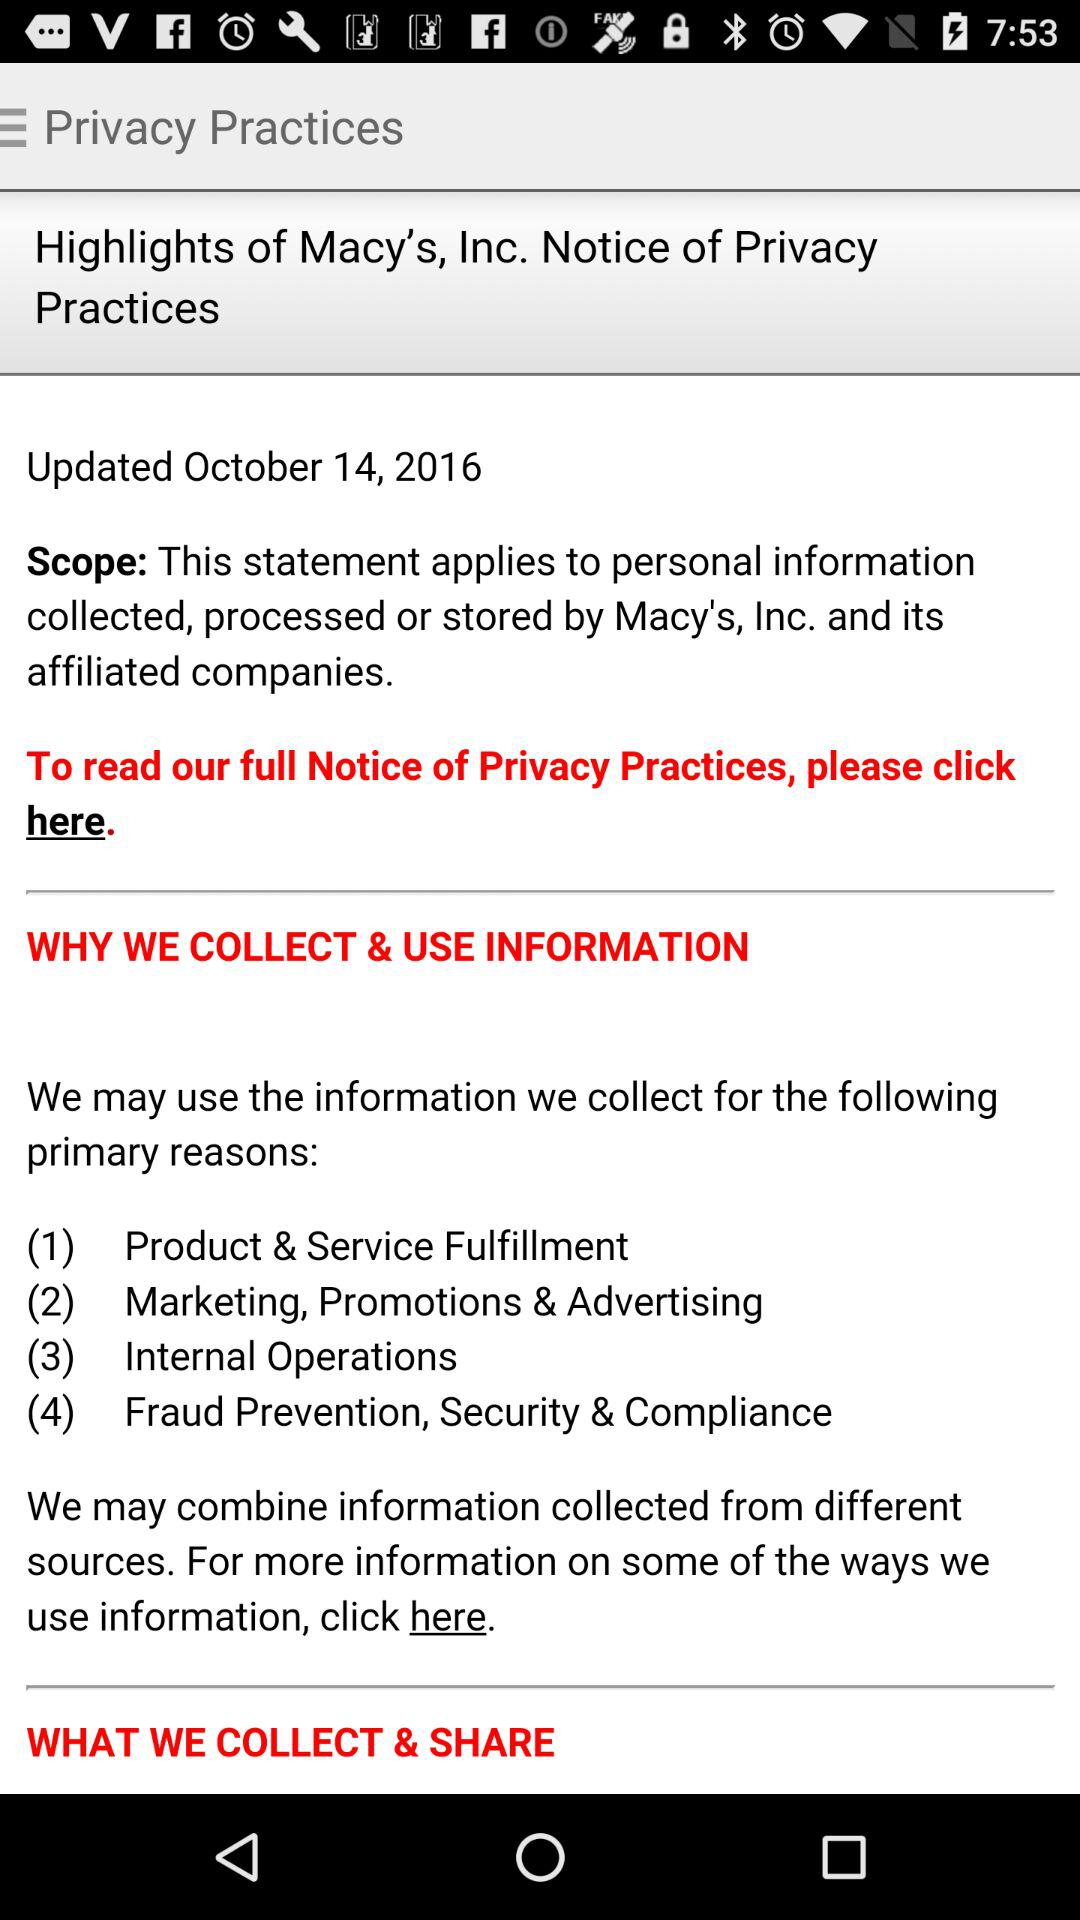What kind of information is collected and shared?
When the provided information is insufficient, respond with <no answer>. <no answer> 